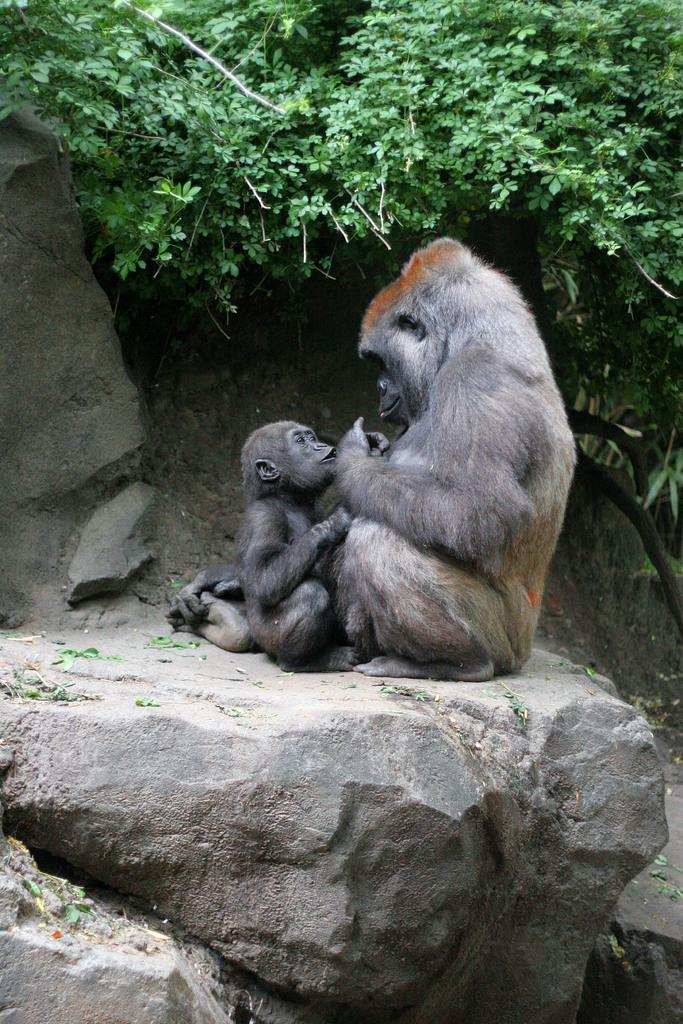How many monkeys are in the image? There are two monkeys in the image. What is the color of the monkeys? The monkeys are black in color. Where are the monkeys sitting in the image? The monkeys are sitting on a rock. What can be seen in the background of the image? There are trees in the background of the image. What is the color of the trees? The trees are green in color. What type of bike can be seen in the image? There is no bike present in the image; it features two black monkeys sitting on a rock with green trees in the background. 